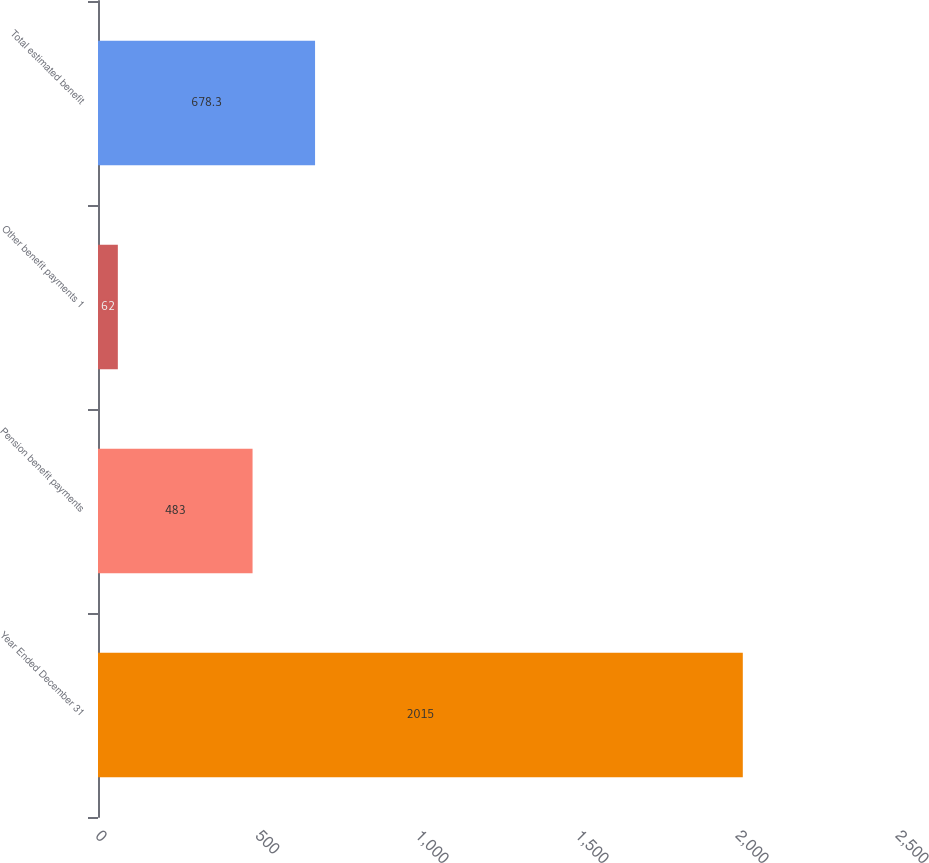Convert chart. <chart><loc_0><loc_0><loc_500><loc_500><bar_chart><fcel>Year Ended December 31<fcel>Pension benefit payments<fcel>Other benefit payments 1<fcel>Total estimated benefit<nl><fcel>2015<fcel>483<fcel>62<fcel>678.3<nl></chart> 